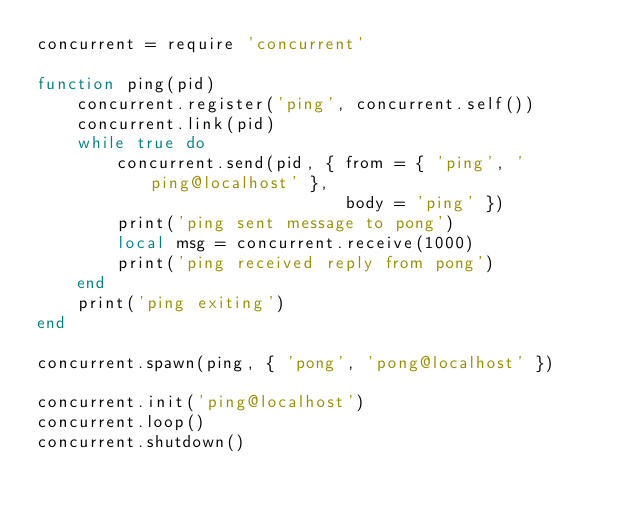Convert code to text. <code><loc_0><loc_0><loc_500><loc_500><_Lua_>concurrent = require 'concurrent'

function ping(pid)
    concurrent.register('ping', concurrent.self())
    concurrent.link(pid)
    while true do
        concurrent.send(pid, { from = { 'ping', 'ping@localhost' },
                               body = 'ping' })
        print('ping sent message to pong')
        local msg = concurrent.receive(1000)
        print('ping received reply from pong')
    end
    print('ping exiting')
end

concurrent.spawn(ping, { 'pong', 'pong@localhost' })

concurrent.init('ping@localhost')
concurrent.loop()
concurrent.shutdown()
</code> 